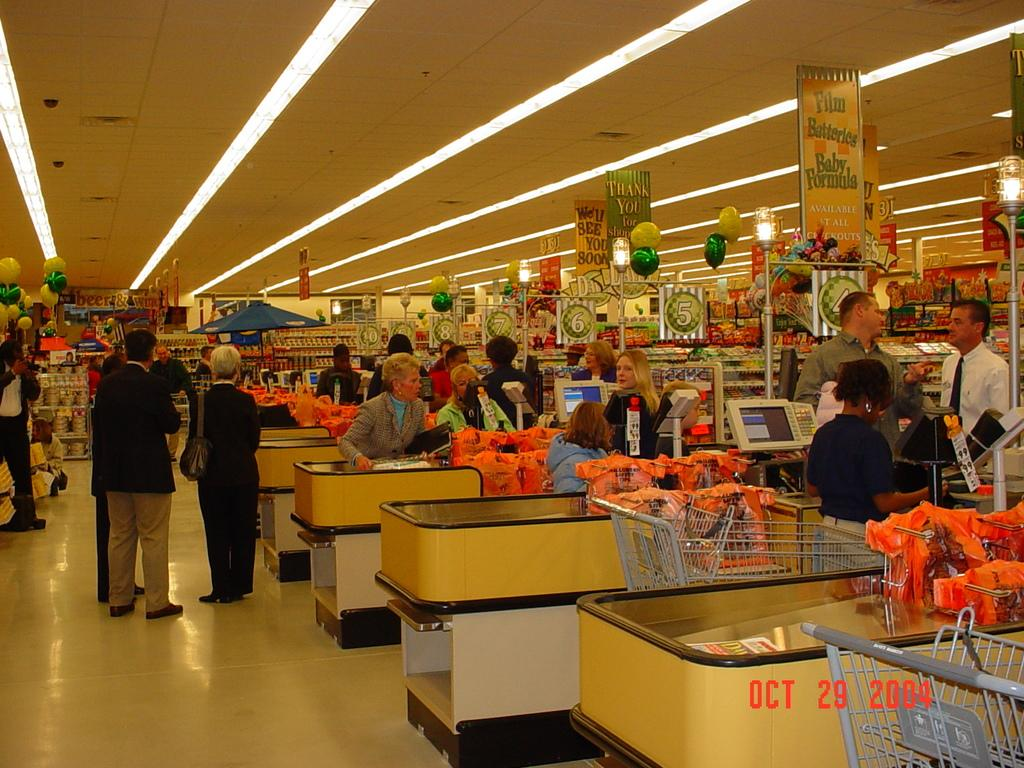How many people can be seen in the image? There are people in the image. What type of surface is present under the people? There is a floor in the image. What objects are used for carrying items in the image? There are carts in the image. What type of display devices are present in the image? There are screens in the image. What type of storage units are present in the image? There are racks in the image. What type of furniture is present in the image for placing items? There are tables in the image. What type of boards are present in the image? There are boards in the image. What type of decorative items are present in the image? There are balloons in the image. What type of surface is present above the people? There is a ceiling in the image. What type of lighting is present in the image? There are lights in the image. What type of vertical structures are present in the image? There are poles in the image. How many ovens can be seen in the image? There are no ovens present in the image. How many girls are present in the image? The provided facts do not specify the gender of the people in the image, so we cannot determine the number of girls. What type of nut is used as a decoration in the image? There is no mention of nuts in the image, so we cannot determine if any are present. 